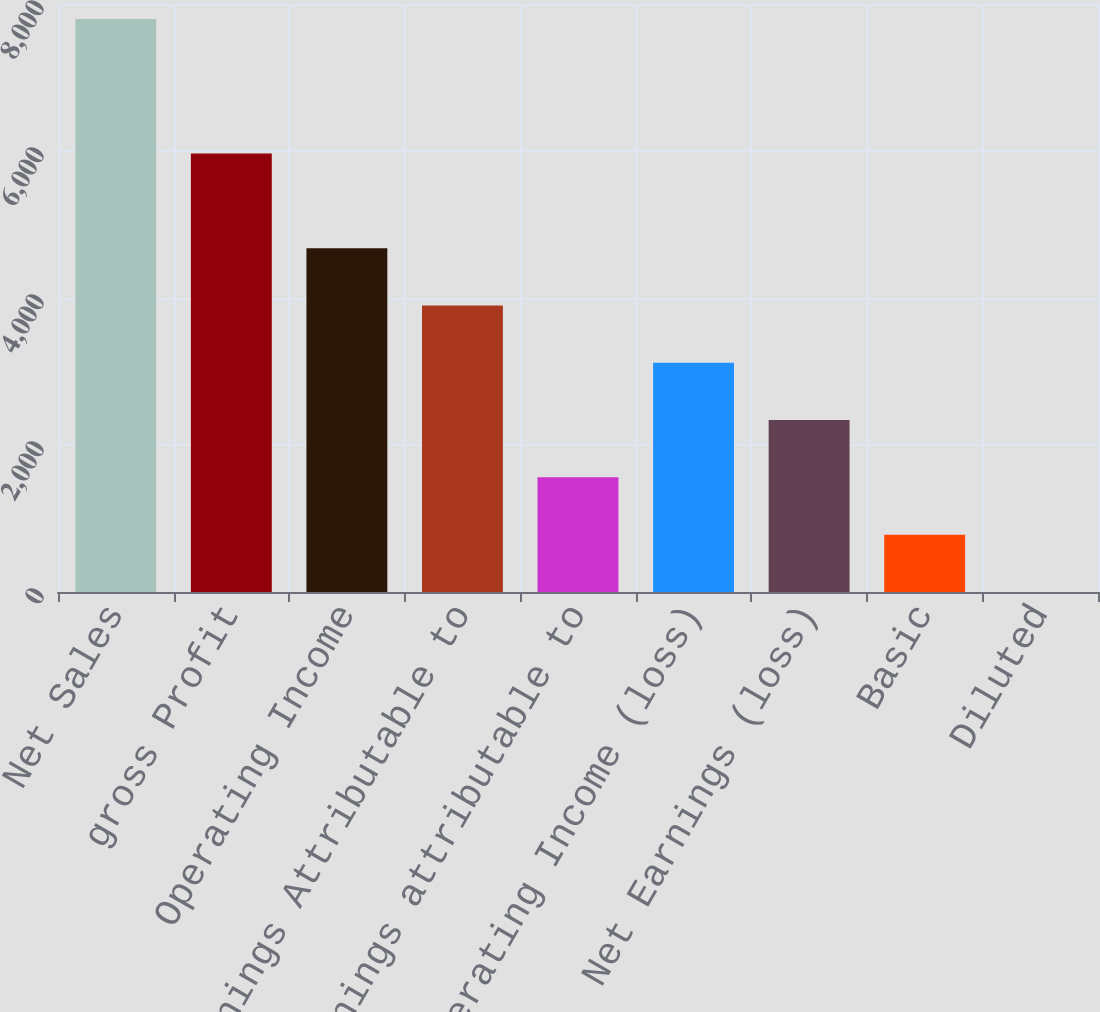Convert chart to OTSL. <chart><loc_0><loc_0><loc_500><loc_500><bar_chart><fcel>Net Sales<fcel>gross Profit<fcel>Operating Income<fcel>Net Earnings Attributable to<fcel>Net earnings attributable to<fcel>Operating Income (loss)<fcel>Net Earnings (loss)<fcel>Basic<fcel>Diluted<nl><fcel>7795.8<fcel>5966.4<fcel>4677.92<fcel>3898.45<fcel>1560.04<fcel>3118.98<fcel>2339.51<fcel>780.57<fcel>1.1<nl></chart> 